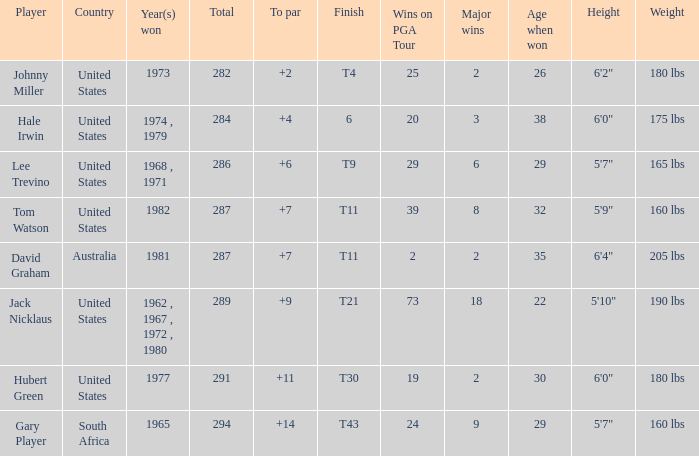WHAT IS THE TO PAR WITH A FINISH OF T11, FOR DAVID GRAHAM? 7.0. 